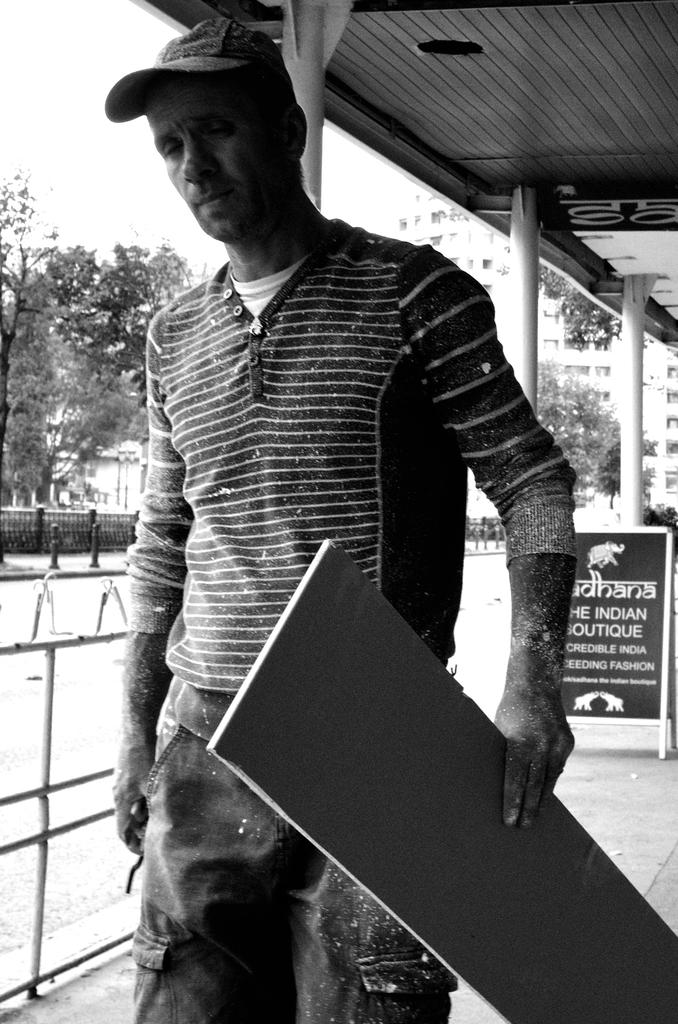What is the man in the image doing? The man is standing in the image and holding a board. What is the man wearing on his head? The man is wearing a wire cap. What can be seen in the background of the image? There is a board, pillars, a building, trees, a fence, and the sky visible in the background of the image. What type of brake is the man using to stop the war in the image? There is no war or brake present in the image. Is the man wearing a mask in the image? No, the man is not wearing a mask in the image; he is wearing a wire cap. 